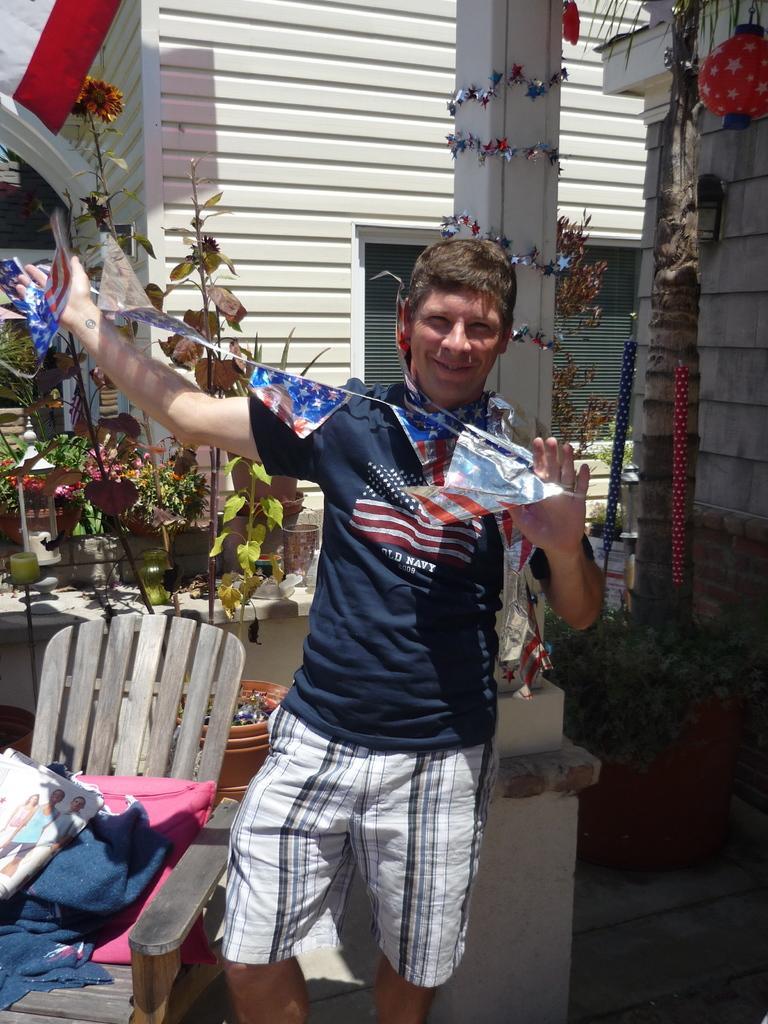Could you give a brief overview of what you see in this image? In this image we can see a man holding a flags in his hands. In the background we can see a building, plants, chairs and pillow in it. 